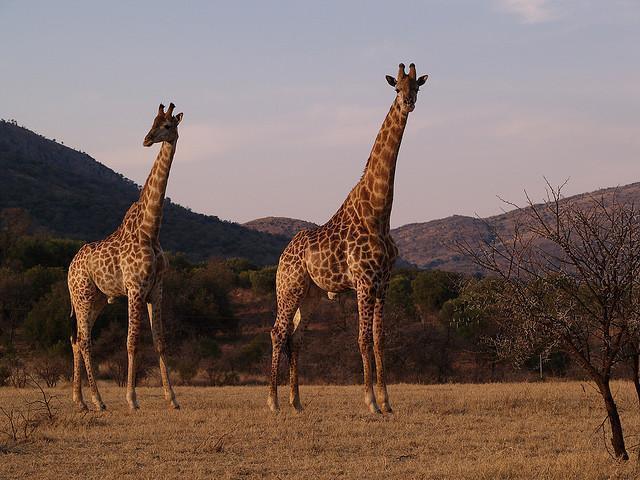How many giraffe are standing in the field?
Give a very brief answer. 2. How many animals are there?
Give a very brief answer. 2. How many giraffes?
Give a very brief answer. 2. How many animals are in the image?
Give a very brief answer. 2. How many giraffes are there?
Give a very brief answer. 2. How many giraffes are visible?
Give a very brief answer. 2. How many bananas have stickers?
Give a very brief answer. 0. 